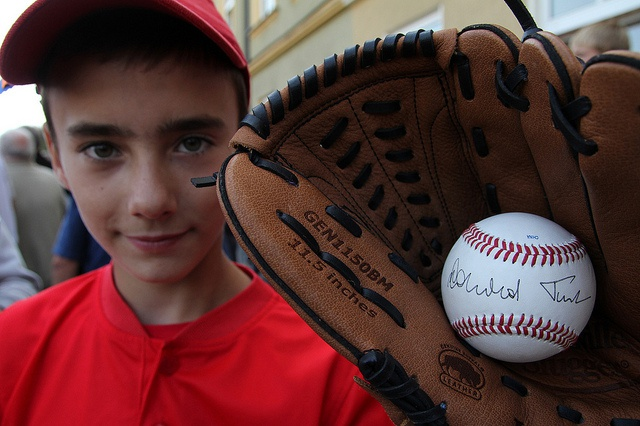Describe the objects in this image and their specific colors. I can see baseball glove in white, black, maroon, brown, and gray tones, people in white, brown, maroon, and black tones, sports ball in white, lightblue, darkgray, and gray tones, people in white, gray, darkgray, and black tones, and people in white, black, gray, navy, and maroon tones in this image. 